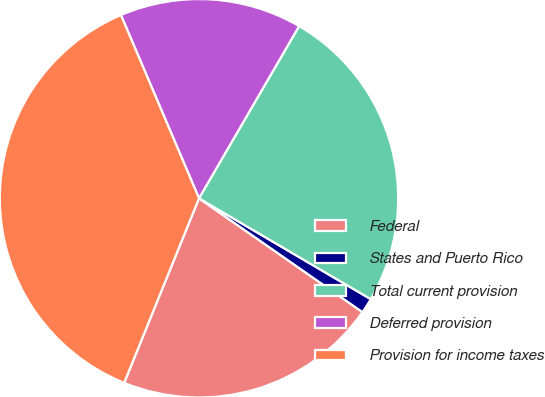Convert chart. <chart><loc_0><loc_0><loc_500><loc_500><pie_chart><fcel>Federal<fcel>States and Puerto Rico<fcel>Total current provision<fcel>Deferred provision<fcel>Provision for income taxes<nl><fcel>21.45%<fcel>1.23%<fcel>25.07%<fcel>14.79%<fcel>37.46%<nl></chart> 